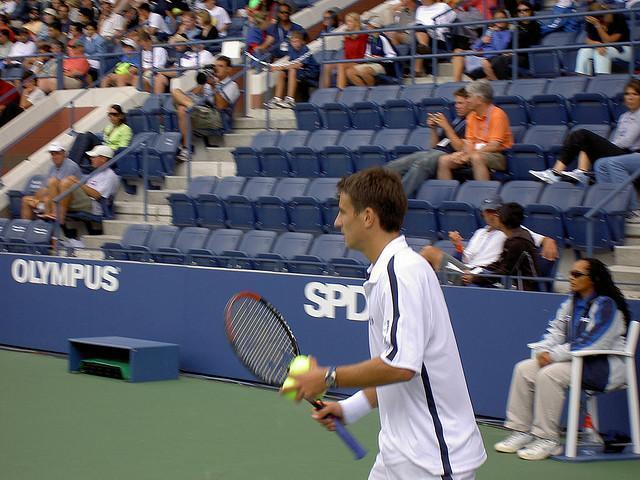How many chairs are there?
Give a very brief answer. 4. How many people are in the photo?
Give a very brief answer. 8. 